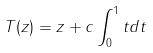<formula> <loc_0><loc_0><loc_500><loc_500>T ( z ) = z + c \int _ { 0 } ^ { 1 } t d t</formula> 